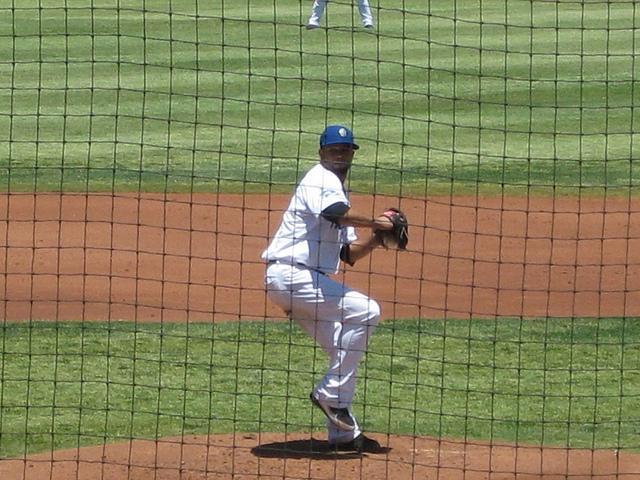How many players can be seen?
Give a very brief answer. 2. 